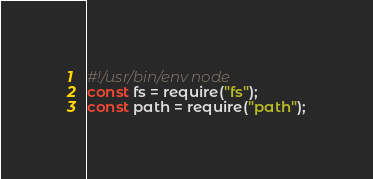Convert code to text. <code><loc_0><loc_0><loc_500><loc_500><_JavaScript_>#!/usr/bin/env node
const fs = require("fs");
const path = require("path");</code> 